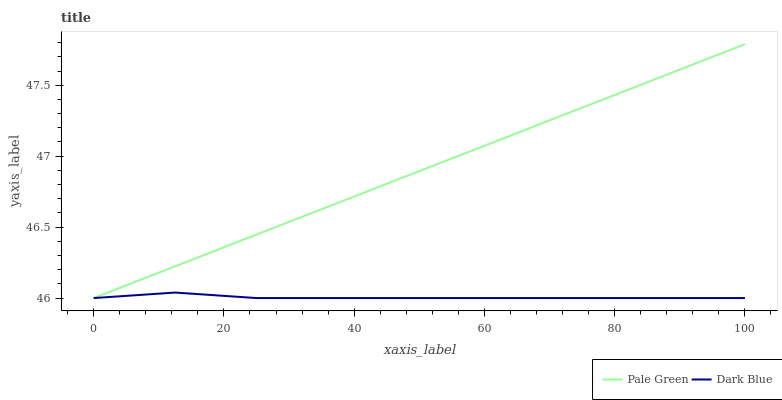Does Dark Blue have the minimum area under the curve?
Answer yes or no. Yes. Does Pale Green have the maximum area under the curve?
Answer yes or no. Yes. Does Pale Green have the minimum area under the curve?
Answer yes or no. No. Is Pale Green the smoothest?
Answer yes or no. Yes. Is Dark Blue the roughest?
Answer yes or no. Yes. Is Pale Green the roughest?
Answer yes or no. No. Does Dark Blue have the lowest value?
Answer yes or no. Yes. Does Pale Green have the highest value?
Answer yes or no. Yes. Does Pale Green intersect Dark Blue?
Answer yes or no. Yes. Is Pale Green less than Dark Blue?
Answer yes or no. No. Is Pale Green greater than Dark Blue?
Answer yes or no. No. 